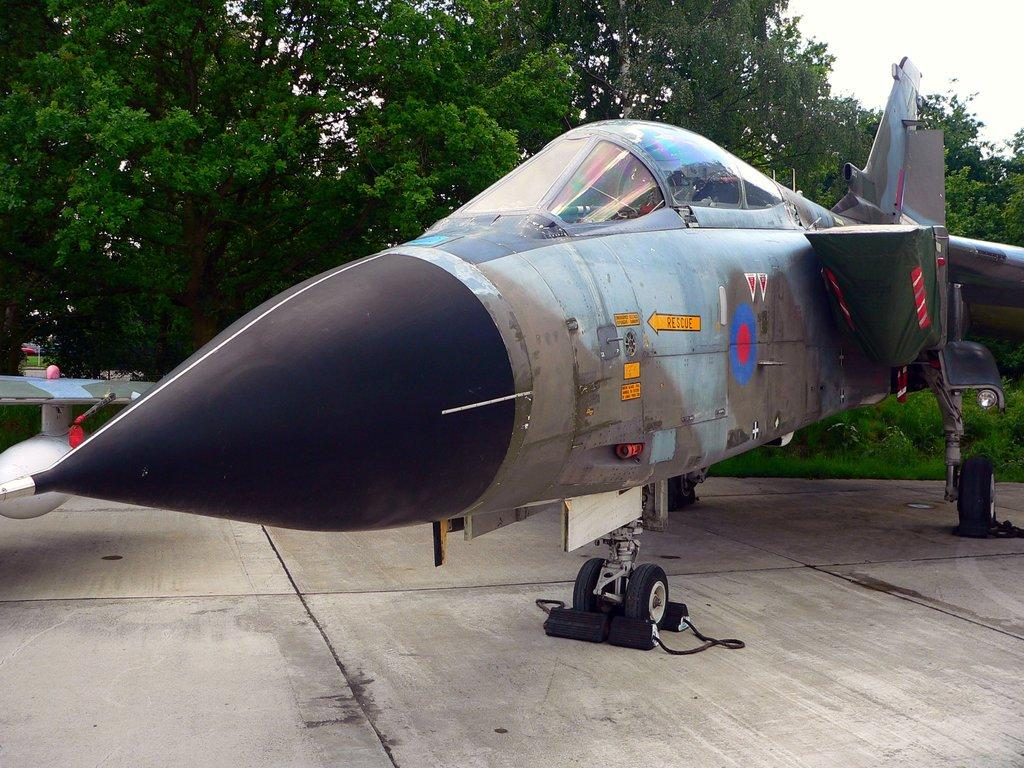What is placed on the floor in the image? There is a flight on the floor in the image. What type of natural environment is depicted in the image? There are trees and grass in the image, which suggests a natural setting. What can be seen in the sky in the image? The sky is visible in the image. How can someone join the flight in the image? There is no indication in the image that someone can join the flight, as it is a static object on the floor. 